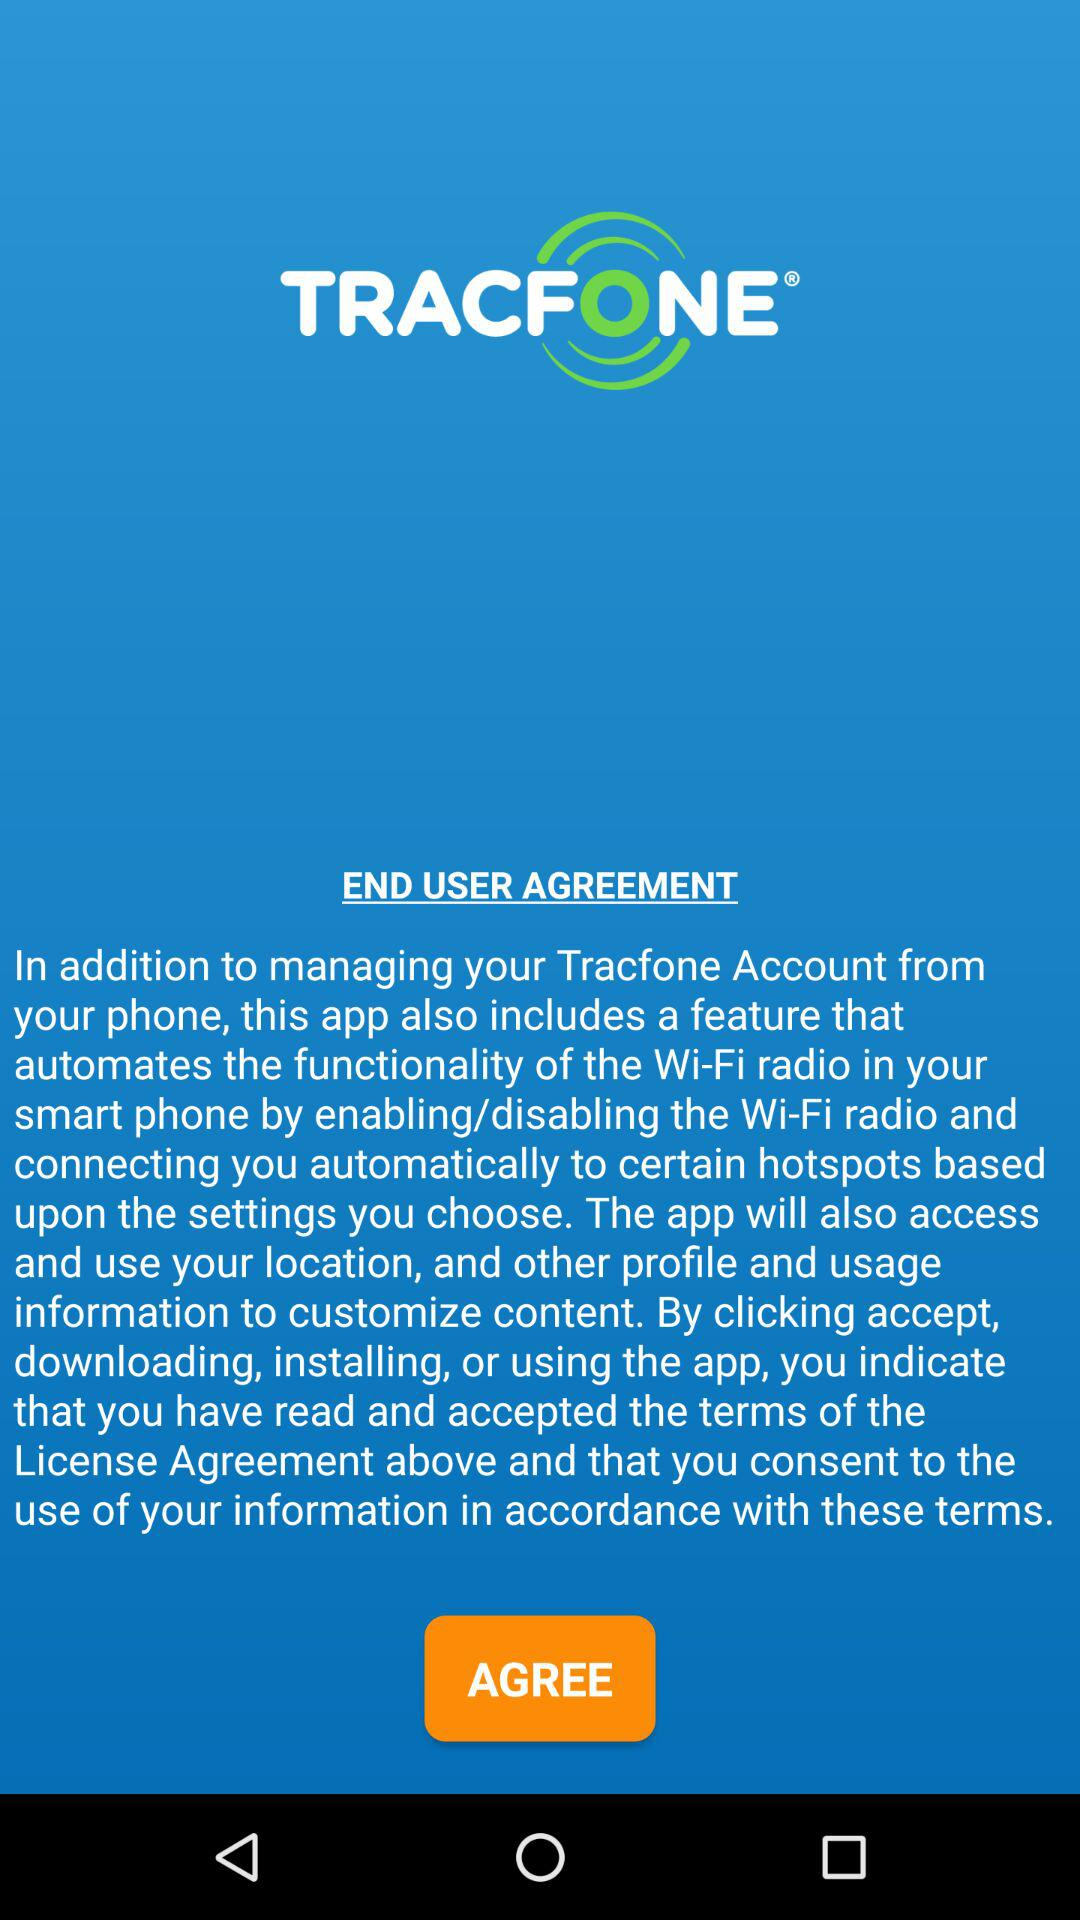What is the name of the application? The name of the application is "TRACFONE". 